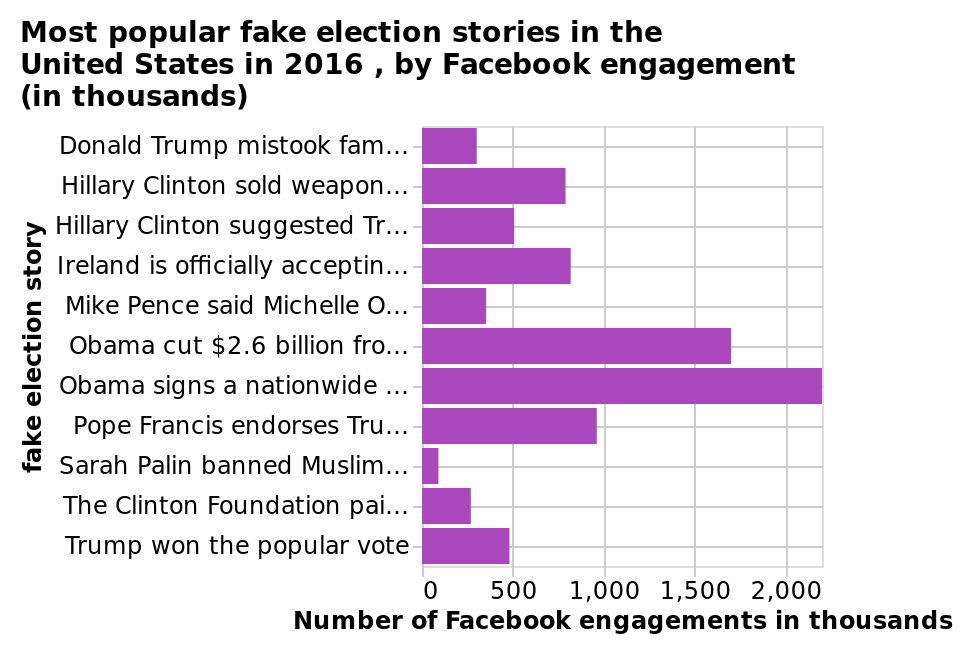<image>
please describe the details of the chart Here a bar plot is called Most popular fake election stories in the United States in 2016 , by Facebook engagement (in thousands). The x-axis plots Number of Facebook engagements in thousands as linear scale of range 0 to 2,000 while the y-axis plots fake election story on categorical scale starting at Donald Trump mistook famous drag queen RuPaul for a woman and groped him at a party in 1995 and ending at Trump won the popular vote. 